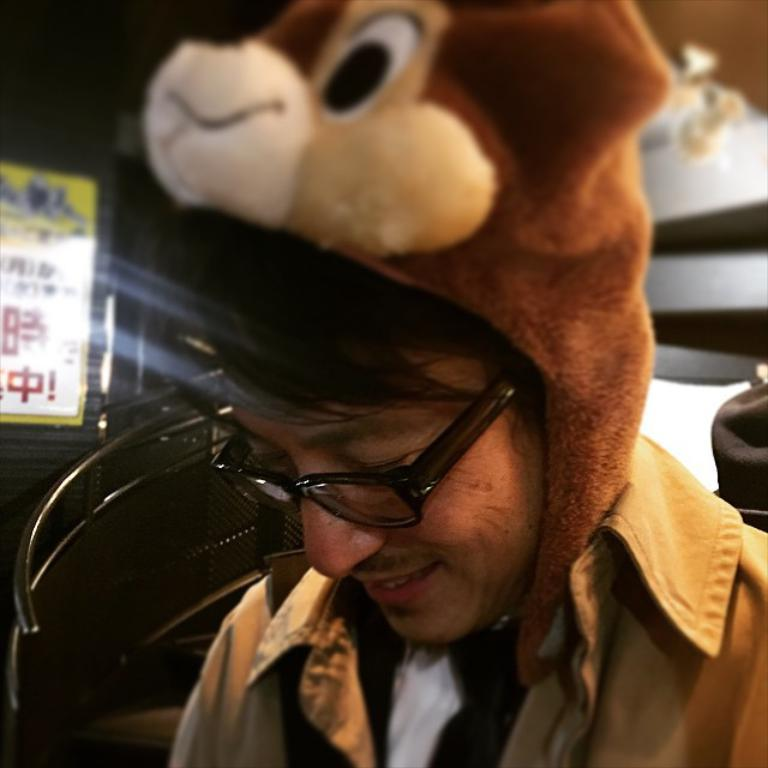Who is present in the image? There is a man in the image. What is the man wearing on his upper body? The man is wearing a brown jacket. What type of hat is the man wearing? The man is wearing a teddy bear hat on his head. What can be seen on the left side of the image? There is a staircase on the left side of the image. What is written or displayed on the board behind the staircase? There is a board with text behind the staircase. How many groups or clubs are visible in the image? There are no groups or clubs visible in the image; it features a man wearing a teddy bear hat and a brown jacket, with a staircase and a board with text in the background. 